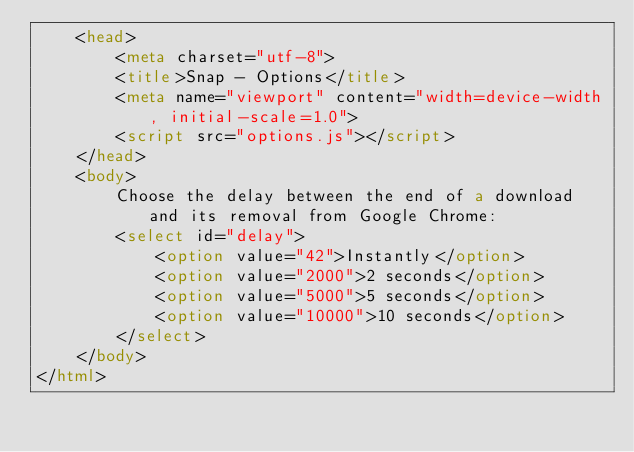<code> <loc_0><loc_0><loc_500><loc_500><_HTML_>    <head>
        <meta charset="utf-8">
        <title>Snap - Options</title>
        <meta name="viewport" content="width=device-width, initial-scale=1.0">
        <script src="options.js"></script>
    </head>
    <body>
        Choose the delay between the end of a download and its removal from Google Chrome:
        <select id="delay">
            <option value="42">Instantly</option>
            <option value="2000">2 seconds</option>
            <option value="5000">5 seconds</option>
            <option value="10000">10 seconds</option>
        </select>
    </body>
</html>
</code> 